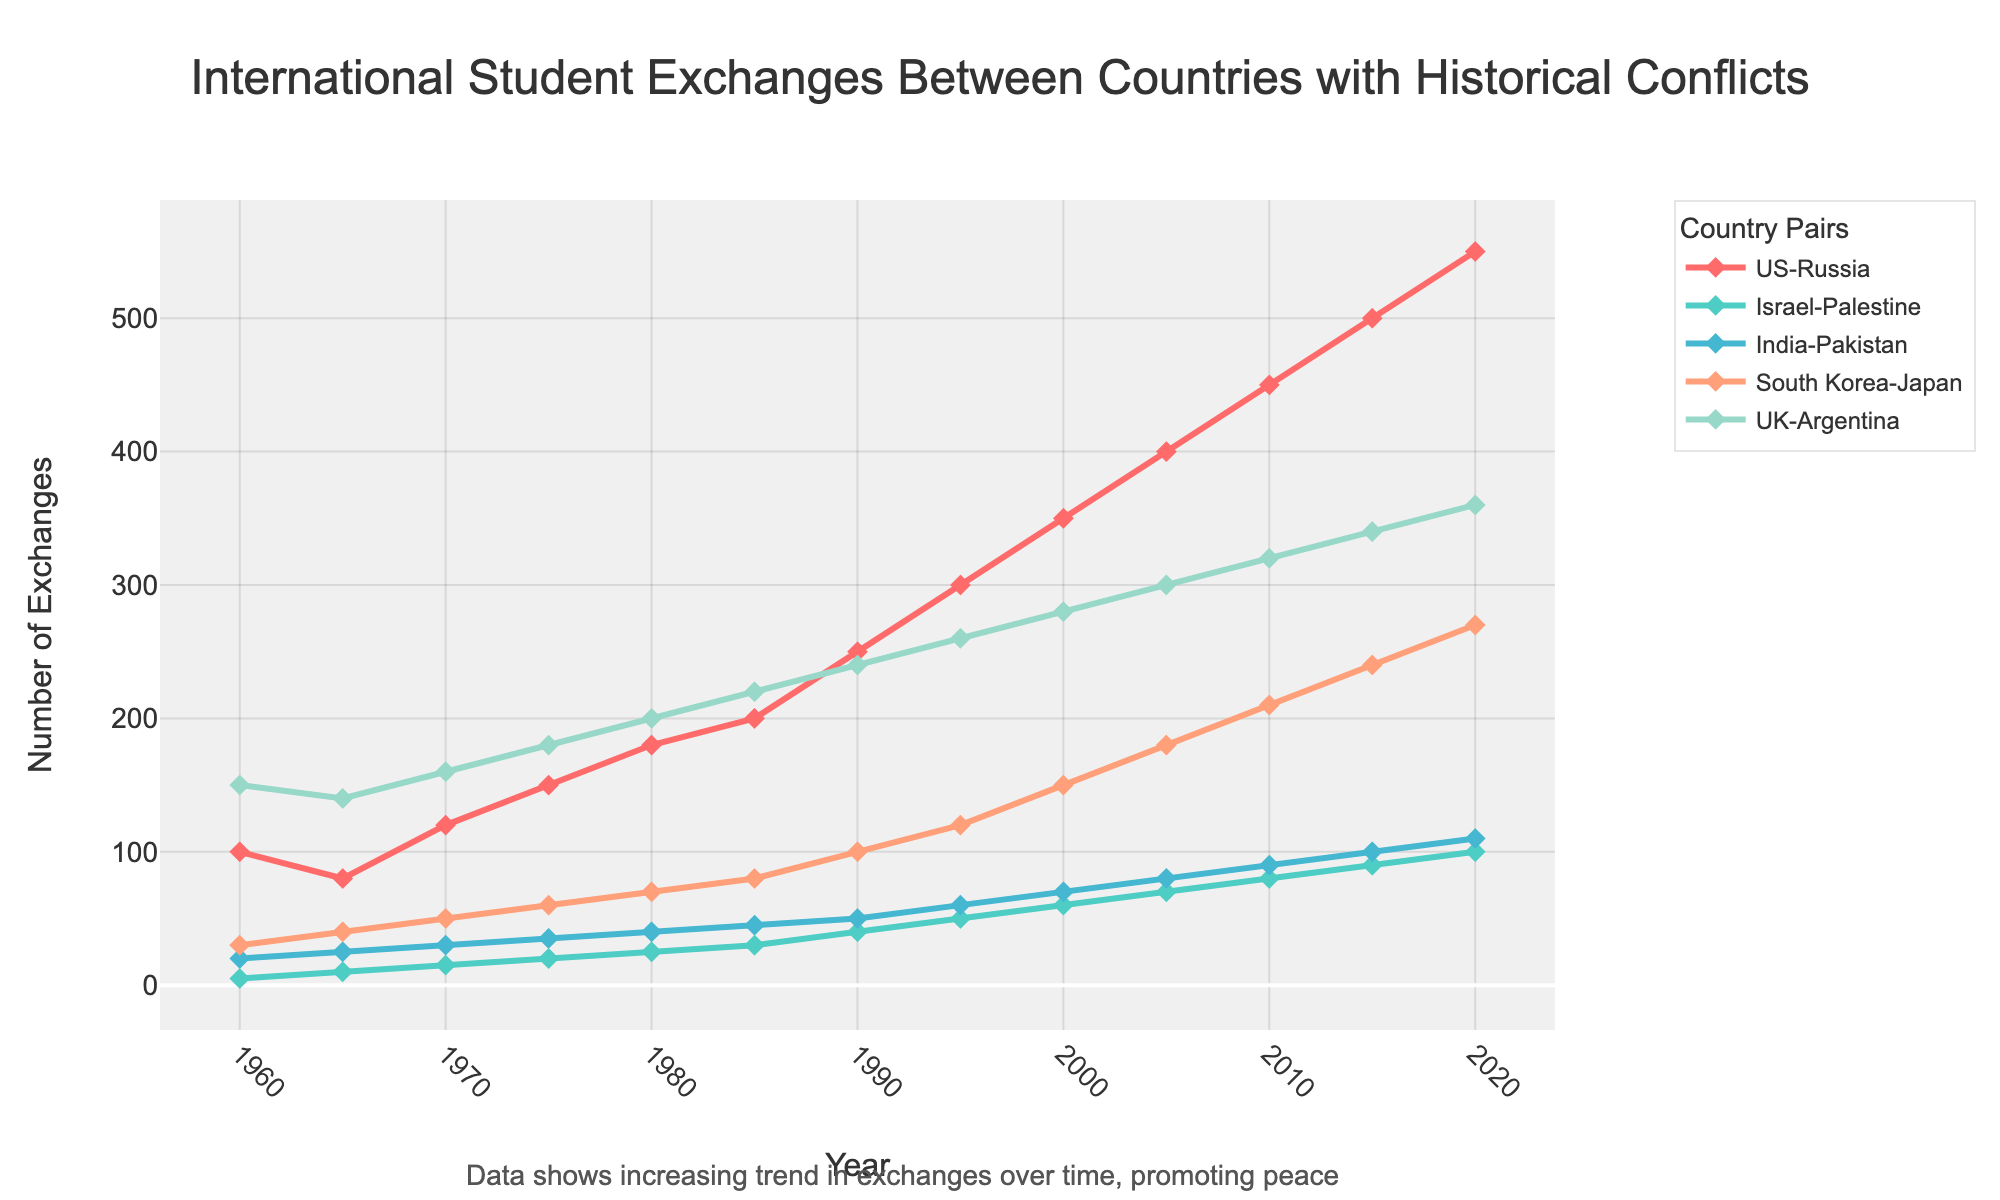What is the trend in international student exchanges between the US and Russia from 1960 to 2020? The number of exchanges between the US and Russia steadily increases over the years from 100 in 1960 to 550 in 2020. This indicates a positive trend despite historical conflicts.
Answer: Increasing Which country pair showed the slowest initial growth in student exchanges and eventually increased in the later decades? Both Israel-Palestine and India-Pakistan started with relatively low exchange rates, but India-Pakistan saw more consistent increases starting from 1985 onwards, signaling slow but significant growth.
Answer: Israel-Palestine How does the growth in student exchanges between the UK and Argentina compare to the growth between South Korea and Japan from 1960 to 2020? The UK and Argentina showed a steady and consistent increase from 150 to 360, while South Korea and Japan showed a slower start but saw more dramatic growth, especially from 1995 to 2020, reaching 270 exchanges.
Answer: UK-Argentina: Steady; South Korea-Japan: Dramatic growth after 1995 In which year did India and Pakistan experience the sharpest increase in student exchanges, and by how much did it increase compared to the previous data point? From 1960 to 2020, the sharpest increase for India-Pakistan occurred between 1990 and 1995, with the number of exchanges growing from 50 to 60. The increase was 10.
Answer: 1995; increase by 10 Which two-country pairs had similar counts of student exchanges in 2010, and what was the count? In 2010, Israel-Palestine and India-Pakistan had similar counts of student exchanges, both with levels around 90.
Answer: Israel-Palestine and India-Pakistan; 90 When did the exchanges between Israel and Palestine reach a count of 50, and what can be said about the trend leading up to this point? In 1995, the exchanges between Israel and Palestine reached 50. The trend leading up to this point shows steady and gradual growth from 5 in 1960, indicating a slow yet positive upward trend in student exchanges.
Answer: 1995; steady growth Was there any year where the number of exchanges between any country pairs decreased? If so, provide an example. Yes, from 1960 to 1965, the number of exchanges between the US and Russia decreased from 100 to 80. This indicates a temporary decline before the numbers started increasing again.
Answer: 1965; US-Russia Compare the total increase in student exchanges from 1960 to 2020 between the two pairs: South Korea-Japan and UK-Argentina. South Korea-Japan increased by (270 - 30 = 240), while UK-Argentina increased by (360 - 150 = 210). South Korea-Japan had a greater total increase in exchanges by 30.
Answer: South Korea-Japan: 240; UK-Argentina: 210 Which color represents the South Korea-Japan exchanges in the line chart, and why is it important for visual analysis? South Korea-Japan is represented by a blue line in the chart. This is important for visual analysis as it allows for easy differentiation between the different country pairs, improving the clarity of the data representation.
Answer: Blue By how much did the number of exchanges between the US and Russia increase from 1985 to 1990, and what does this say about the period? The number of exchanges increased from 200 in 1985 to 250 in 1990, an increase of 50. This suggests a significant growth during this period, possibly indicating improved relations or policies encouraging exchanges.
Answer: Increase by 50 